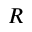Convert formula to latex. <formula><loc_0><loc_0><loc_500><loc_500>R</formula> 